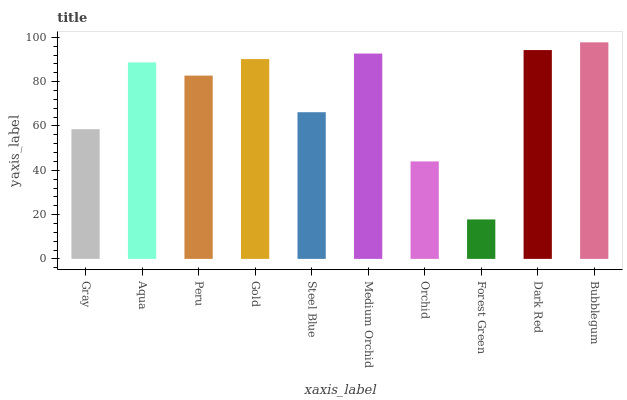Is Forest Green the minimum?
Answer yes or no. Yes. Is Bubblegum the maximum?
Answer yes or no. Yes. Is Aqua the minimum?
Answer yes or no. No. Is Aqua the maximum?
Answer yes or no. No. Is Aqua greater than Gray?
Answer yes or no. Yes. Is Gray less than Aqua?
Answer yes or no. Yes. Is Gray greater than Aqua?
Answer yes or no. No. Is Aqua less than Gray?
Answer yes or no. No. Is Aqua the high median?
Answer yes or no. Yes. Is Peru the low median?
Answer yes or no. Yes. Is Forest Green the high median?
Answer yes or no. No. Is Steel Blue the low median?
Answer yes or no. No. 